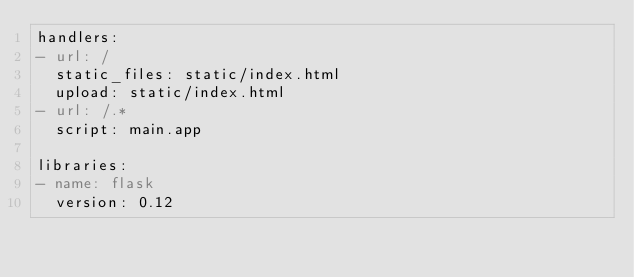Convert code to text. <code><loc_0><loc_0><loc_500><loc_500><_YAML_>handlers:
- url: /
  static_files: static/index.html
  upload: static/index.html
- url: /.*
  script: main.app

libraries:
- name: flask
  version: 0.12</code> 